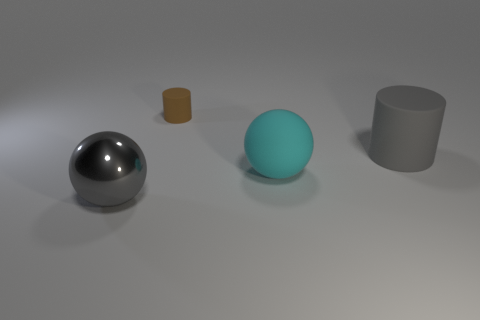Add 3 large gray cylinders. How many objects exist? 7 Subtract 1 balls. How many balls are left? 1 Subtract all gray spheres. How many spheres are left? 1 Subtract all big cubes. Subtract all cylinders. How many objects are left? 2 Add 3 gray metal things. How many gray metal things are left? 4 Add 2 red blocks. How many red blocks exist? 2 Subtract 0 green cylinders. How many objects are left? 4 Subtract all blue cylinders. Subtract all gray balls. How many cylinders are left? 2 